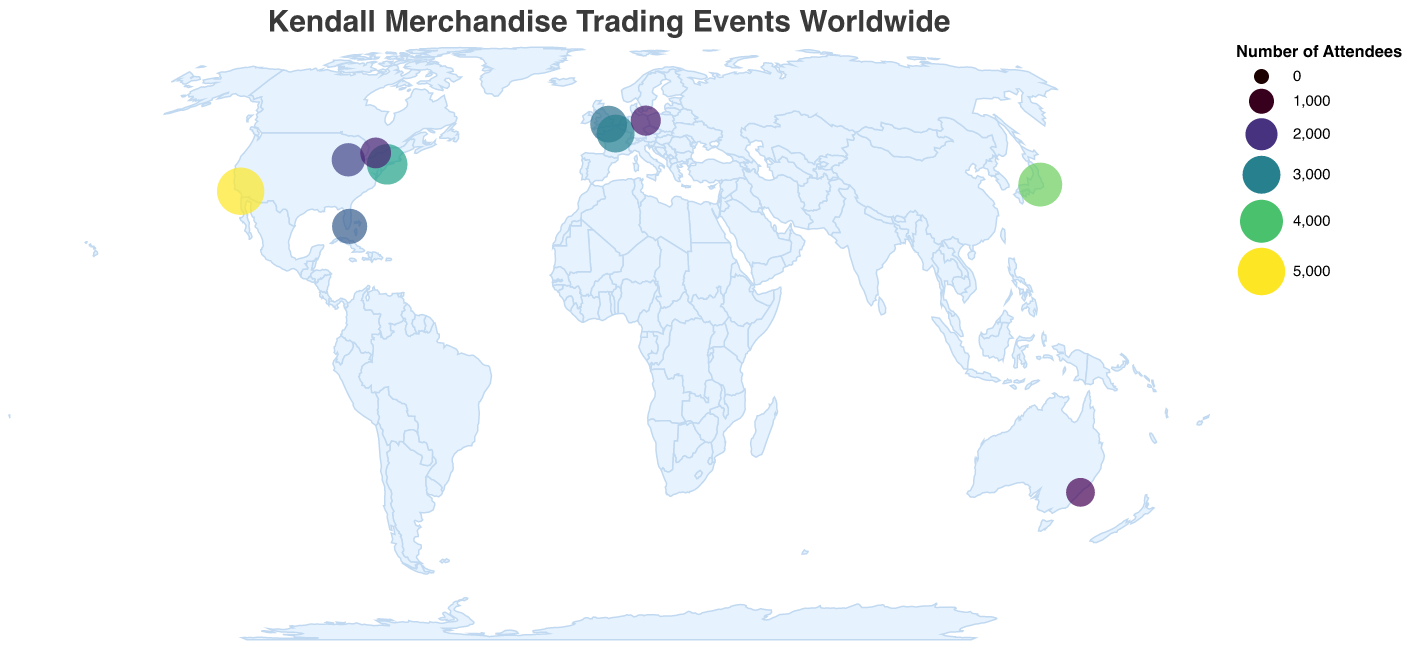What is the title of the figure? The title of the figure is positioned at the top and typically summarizes the main topic of the plot.
Answer: Kendall Merchandise Trading Events Worldwide Which city hosts the event with the highest number of attendees? By looking at the size of the circles and the corresponding data points, the largest circle, indicating the highest number of attendees, belongs to Los Angeles.
Answer: Los Angeles What is the average number of attendees for all the events? Sum the number of attendees for all events: 5000+3500+2800+4200+1500+2200+3000+1800+2500+1700 = 26200. Divide this sum by the number of events (10) to get the average: 26200/10.
Answer: 2620 Which cities have more than 3000 attendees at their events? Check and compare the circle sizes and corresponding data values for attendee numbers. The events in Los Angeles, New York City, and Tokyo each have more than 3000 attendees.
Answer: Los Angeles, New York City, Tokyo Which event is located furthest to the south? The latitude is a measure of how far north or south a location is. A more negative latitude indicates a more southern location. Sydney, with its latitude of -33.8688, is the furthest south.
Answer: Sydney Which event has fewer attendees, the one in Berlin or the one in Chicago? Compare the circle sizes or attendee numbers for the events in Berlin and Chicago. Berlin has 1700 attendees, while Chicago has 2200.
Answer: Berlin What's the total number of attendees combined for events held in Europe? Sum the number of attendees for European locations: London (2800) + Paris (3000) + Berlin (1700) = 7500.
Answer: 7500 What is the smallest number of attendees at any event? Look for the smallest circle or the lowest value in the attendee numbers. The smallest number is 1500, which is for the event in Sydney.
Answer: 1500 Which city has the closest number of attendees to the average attendance of the events? Calculate the absolute difference between the number of attendees at each event and the average (2620). The closest is Paris with 3000 attendees, which is 380 away from the average.
Answer: Paris 